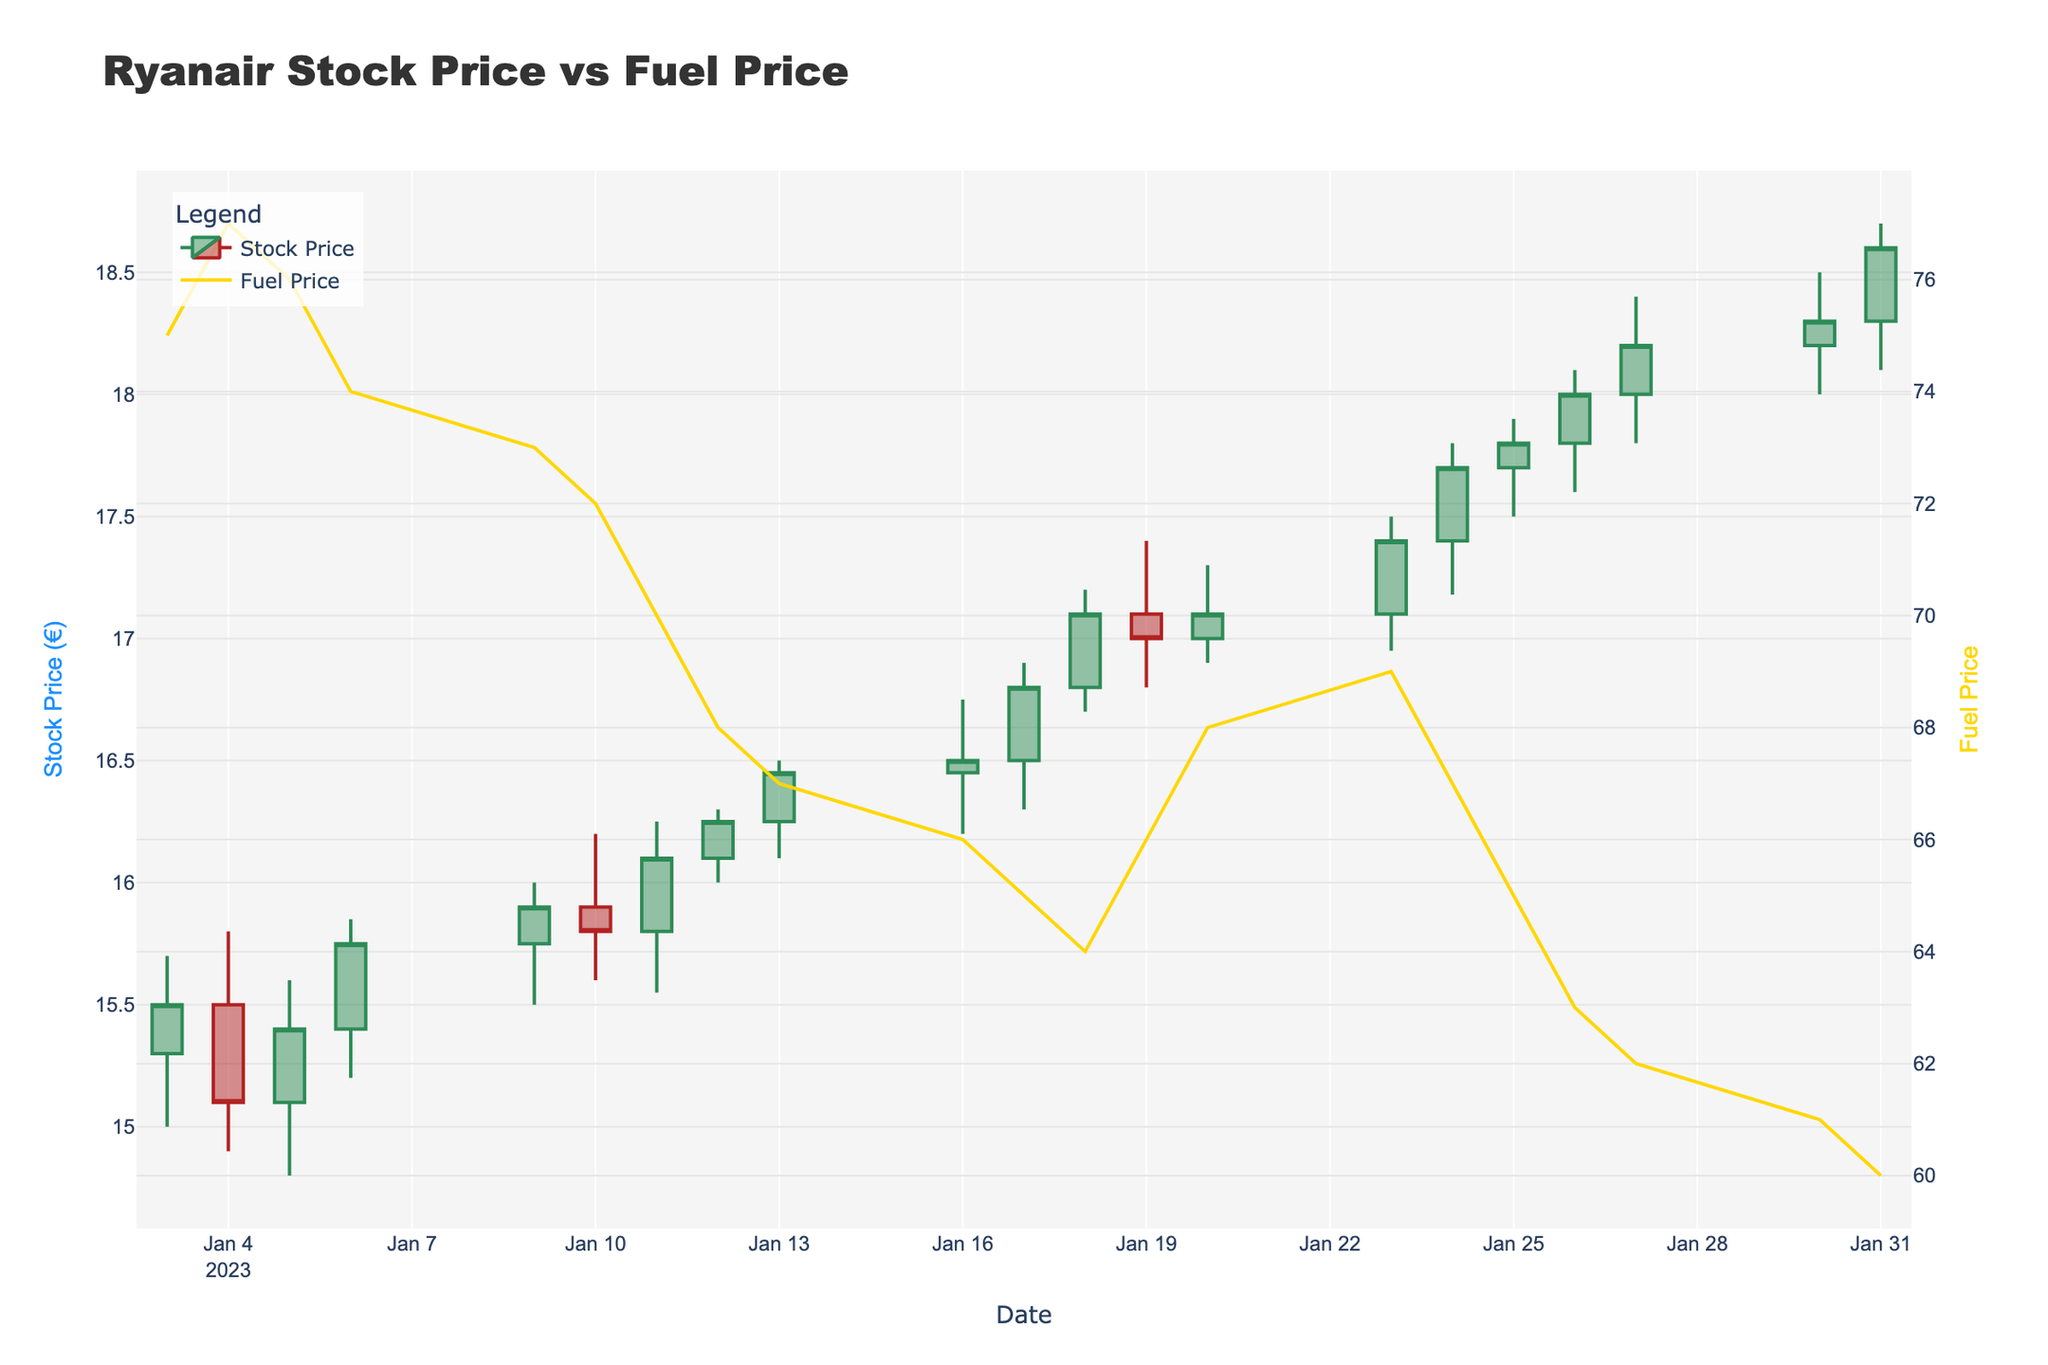What is the title of the figure? The title of the figure is usually displayed at the top and is the main heading that describes what the figure is about. Here, it is "Ryanair Stock Price vs Fuel Price".
Answer: Ryanair Stock Price vs Fuel Price How many data points are shown in the plot? By counting the dates on the x-axis, we can determine the number of data points. There are data points for each trading day from January 3 to January 31, 2023.
Answer: 21 What colors are used to represent increasing and decreasing stock prices? In candlestick plots, the colors represent whether the stock price has increased or decreased. Here, increasing prices are green, and decreasing prices are red.
Answer: Green for increasing, red for decreasing What is the highest stock price observed in January 2023? By looking at the highest points of the upper wicks of the candlesticks, we can find the maximum value. The highest price is 18.70 on January 31, 2023.
Answer: 18.70 Compare the stock price on January 3rd and January 31st. Did it increase or decrease? By checking the stock prices at the beginning (Open on January 3rd at 15.30) and the end (Close on January 31st at 18.60), we can see that it increased.
Answer: Increased On which date did the stock price close at one of its highest during the observed period? The candlestick bodies’ top represent the closing prices. The highest closing price is observed on January 31, 2023, at 18.60.
Answer: January 31, 2023 How did the fuel prices trend through January 2023? By looking at the line graph representing fuel prices, we can determine that fuel prices generally decreased over the month, from 75 to 60.
Answer: Decreased Is there any noticeable correlation between fuel prices and Ryanair's stock price during January 2023? Observing both the candlestick plot and the line graph, as fuel prices decreased, Ryanair’s stock price generally increased, suggesting an inverse correlation.
Answer: Inverse correlation What was the fuel price on January 12, 2023? By looking at the line graph representing fuel prices, we can check the fuel price at the specific date. On January 12, it was 68.
Answer: 68 What was the stock price range on January 20, 2023? In a candlestick plot, the highest and lowest points of the candle indicate the range. On January 20, the high was 17.30, and the low was 16.90.
Answer: 16.90 to 17.30 